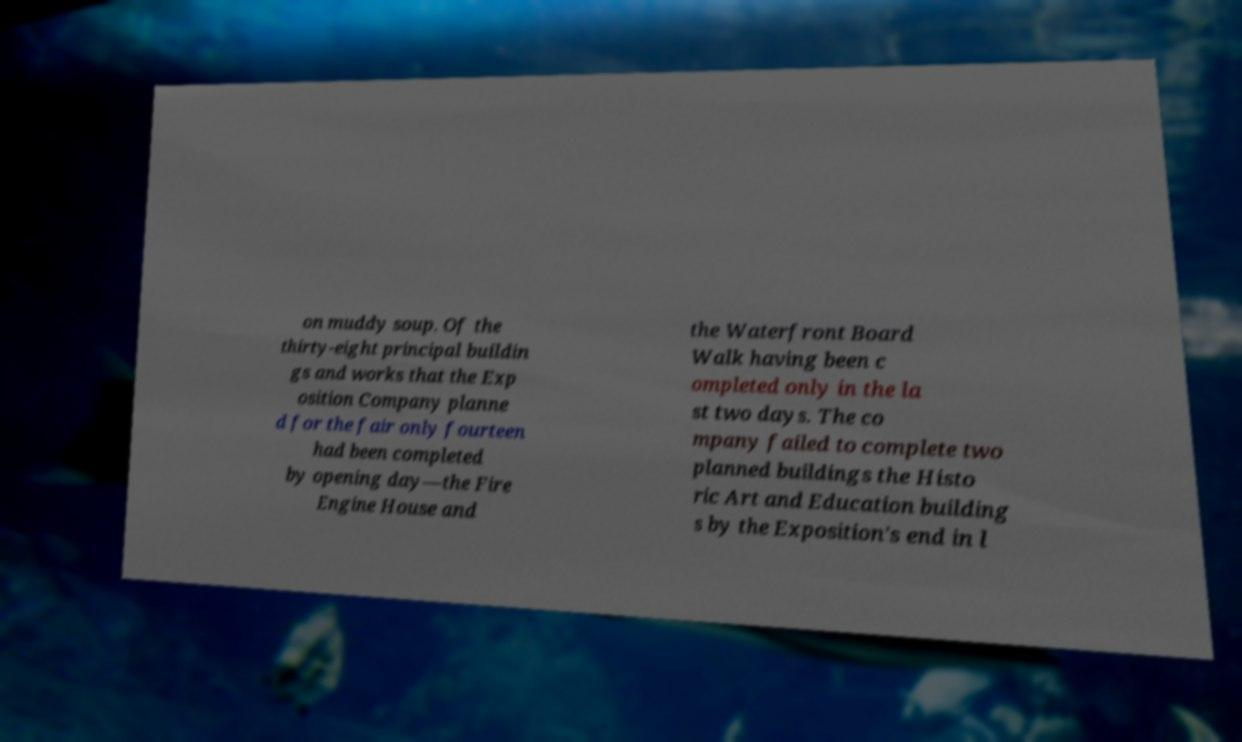Please identify and transcribe the text found in this image. on muddy soup. Of the thirty-eight principal buildin gs and works that the Exp osition Company planne d for the fair only fourteen had been completed by opening day—the Fire Engine House and the Waterfront Board Walk having been c ompleted only in the la st two days. The co mpany failed to complete two planned buildings the Histo ric Art and Education building s by the Exposition's end in l 